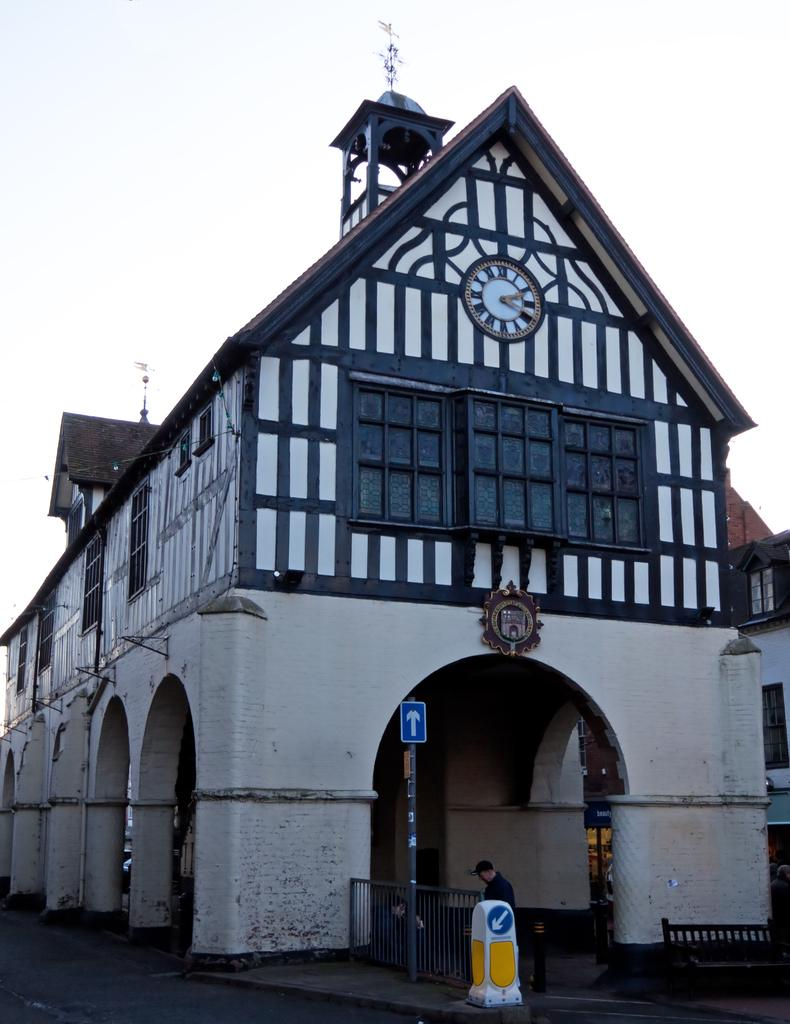What type of structure is visible in the image? There is a building in the image. Can you describe the person's position in relation to the building? There is a person standing near the building. What type of barrier is present in the image? There is fencing in the image. What type of seating is available in the image? There is a bench in the image. What type of material is present in the image? There are boards in the image. Where is the chain located in the image? There is no chain present in the image. What type of underground space is visible in the image? There is no cellar visible in the image. 